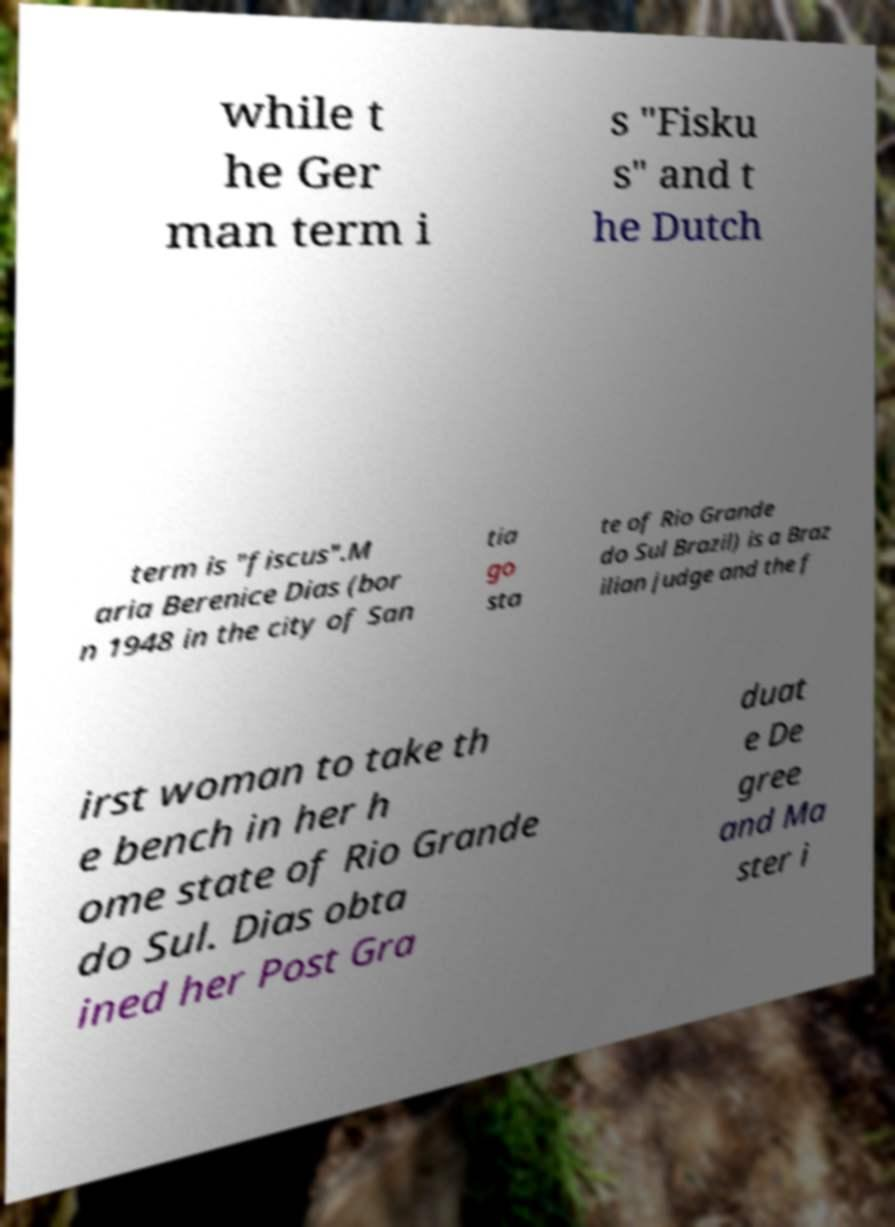I need the written content from this picture converted into text. Can you do that? while t he Ger man term i s "Fisku s" and t he Dutch term is "fiscus".M aria Berenice Dias (bor n 1948 in the city of San tia go sta te of Rio Grande do Sul Brazil) is a Braz ilian judge and the f irst woman to take th e bench in her h ome state of Rio Grande do Sul. Dias obta ined her Post Gra duat e De gree and Ma ster i 